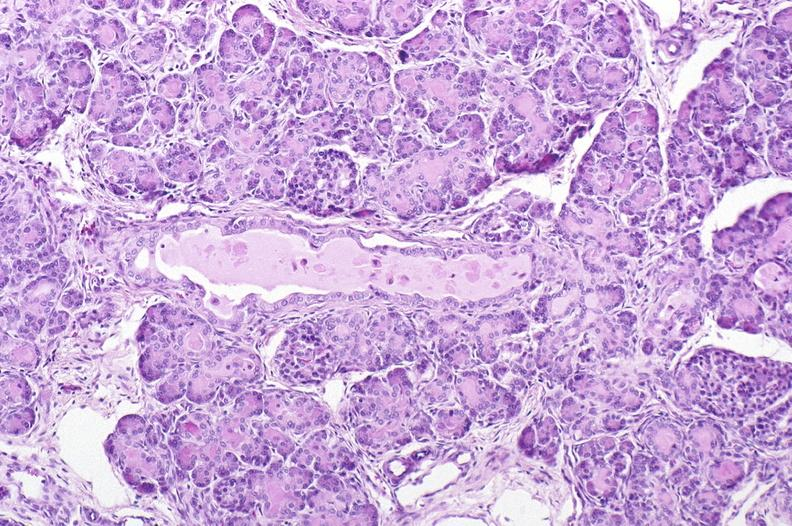does prostate show cystic fibrosis?
Answer the question using a single word or phrase. No 